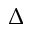Convert formula to latex. <formula><loc_0><loc_0><loc_500><loc_500>\Delta</formula> 